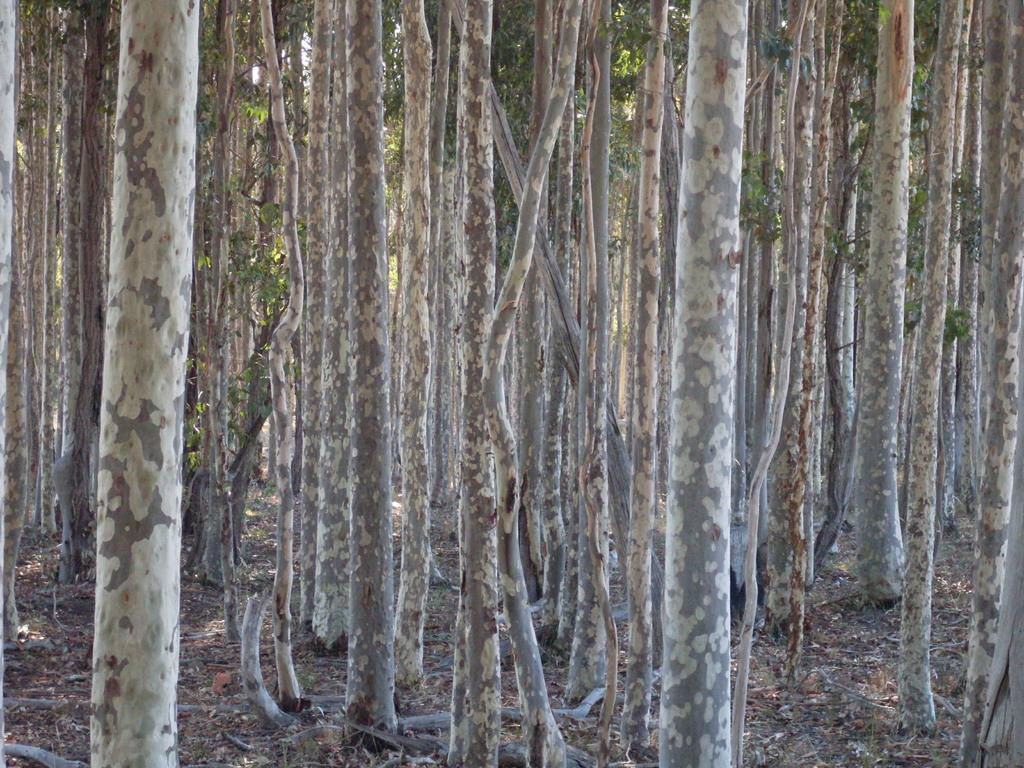What type of vegetation can be seen in the image? There are trees in the image. Can you describe the trees in the image? The provided facts do not include specific details about the trees, so we cannot describe them further. What type of badge can be seen on the tree in the image? There is no badge present on the tree in the image. How does the limit of the trees affect the image? The provided facts do not mention any limits related to the trees, so we cannot determine how they might affect the image. 